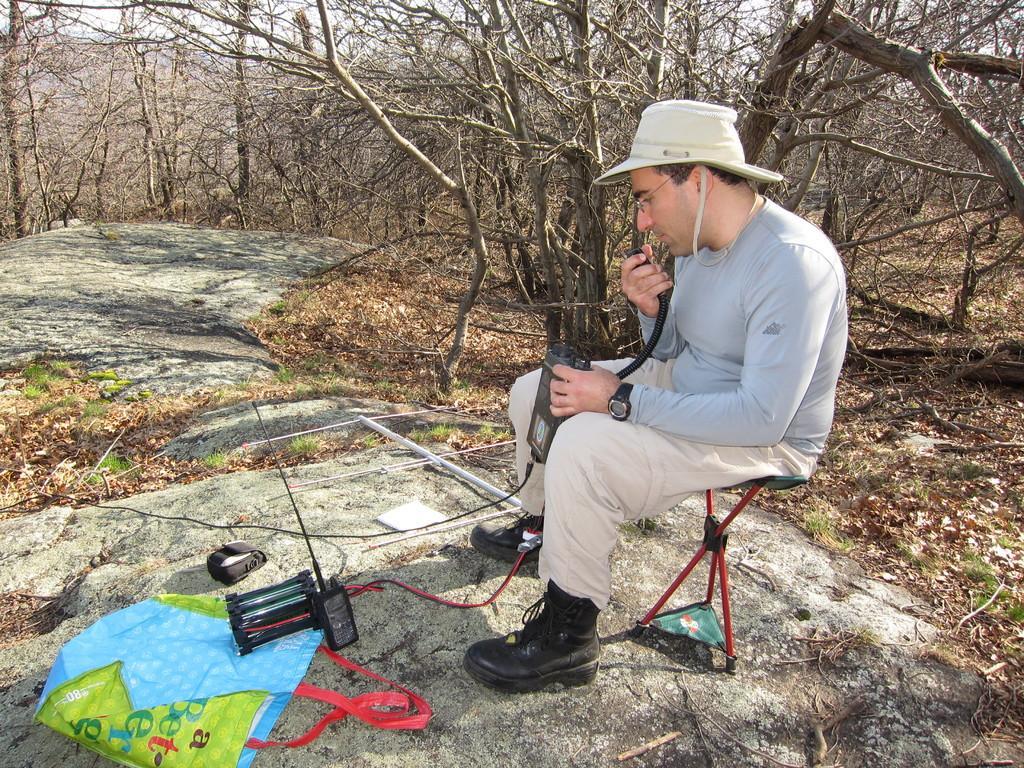How would you summarize this image in a sentence or two? In this picture there is a man sitting and holding the device. At the bottom there is a bag and there are devices. At the back there are trees. At the top there is sky. At the bottom there are dried leaves and there are rocks and there is grass. 